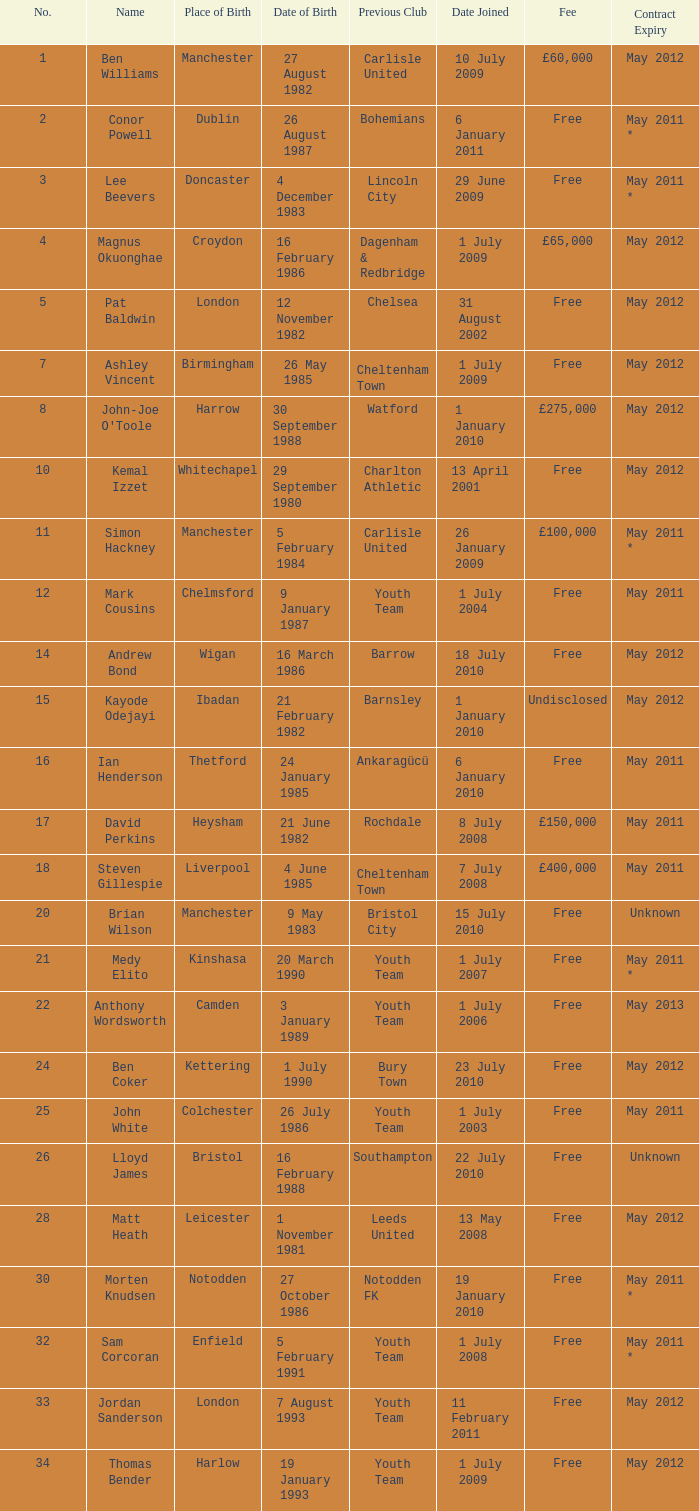For the number 7, what is the birth date? 26 May 1985. 